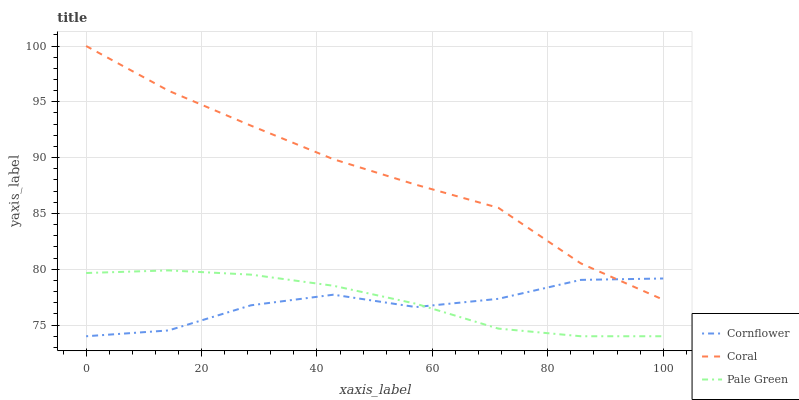Does Cornflower have the minimum area under the curve?
Answer yes or no. Yes. Does Coral have the maximum area under the curve?
Answer yes or no. Yes. Does Pale Green have the minimum area under the curve?
Answer yes or no. No. Does Pale Green have the maximum area under the curve?
Answer yes or no. No. Is Pale Green the smoothest?
Answer yes or no. Yes. Is Cornflower the roughest?
Answer yes or no. Yes. Is Coral the smoothest?
Answer yes or no. No. Is Coral the roughest?
Answer yes or no. No. Does Cornflower have the lowest value?
Answer yes or no. Yes. Does Coral have the lowest value?
Answer yes or no. No. Does Coral have the highest value?
Answer yes or no. Yes. Does Pale Green have the highest value?
Answer yes or no. No. Is Pale Green less than Coral?
Answer yes or no. Yes. Is Coral greater than Pale Green?
Answer yes or no. Yes. Does Coral intersect Cornflower?
Answer yes or no. Yes. Is Coral less than Cornflower?
Answer yes or no. No. Is Coral greater than Cornflower?
Answer yes or no. No. Does Pale Green intersect Coral?
Answer yes or no. No. 